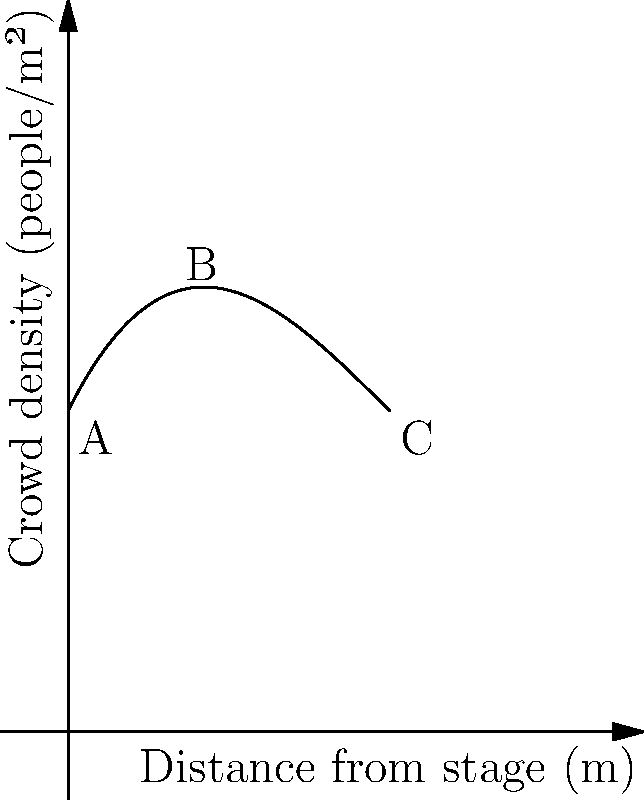At the Darlene Love concert, the crowd density distribution can be modeled by the polynomial function $f(x) = 0.01x^3 - 0.3x^2 + 2x + 10$, where $x$ is the distance from the stage in meters and $f(x)$ is the crowd density in people per square meter. At what distance from the stage is the crowd density at its minimum? To find the minimum point of the crowd density function, we need to follow these steps:

1) First, we need to find the derivative of the function:
   $f'(x) = 0.03x^2 - 0.6x + 2$

2) Set the derivative equal to zero to find the critical points:
   $0.03x^2 - 0.6x + 2 = 0$

3) This is a quadratic equation. We can solve it using the quadratic formula:
   $x = \frac{-b \pm \sqrt{b^2 - 4ac}}{2a}$

   Where $a = 0.03$, $b = -0.6$, and $c = 2$

4) Plugging these values into the quadratic formula:
   $x = \frac{0.6 \pm \sqrt{0.36 - 0.24}}{0.06} = \frac{0.6 \pm \sqrt{0.12}}{0.06}$

5) Simplifying:
   $x = \frac{0.6 \pm 0.346}{0.06} = 10$ or $4.23$

6) The second derivative is $f''(x) = 0.06x - 0.6$
   At $x = 10$, $f''(10) = 0$ (inflection point)
   At $x = 4.23$, $f''(4.23) > 0$ (minimum point)

Therefore, the crowd density is at its minimum approximately 4.23 meters from the stage.
Answer: 4.23 meters 